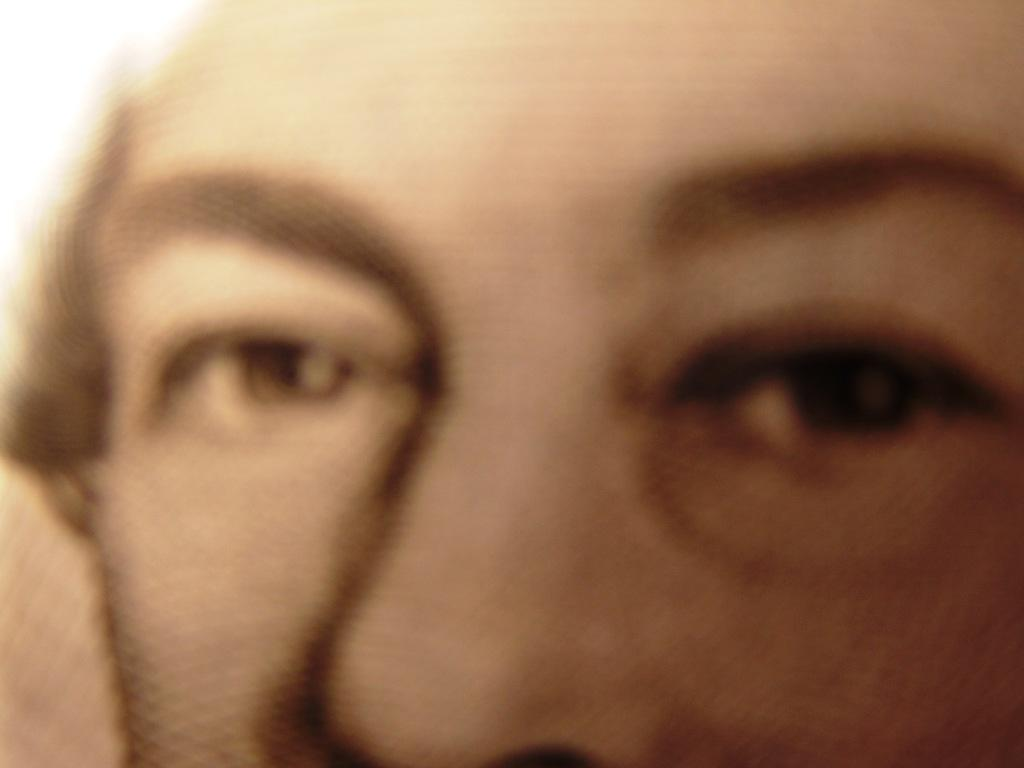What body parts are the focus of the image? The image contains a close-up view of a person's eyes and nose. Can you describe the details of the person's eyes in the image? Unfortunately, the provided facts do not include any details about the person's eyes. Can you describe the details of the person's nose in the image? Unfortunately, the provided facts do not include any details about the person's nose. What type of rifle can be seen in the image? There is no rifle present in the image; it contains a close-up view of a person's eyes and nose. What type of farm animals can be seen in the image? There are no farm animals present in the image; it contains a close-up view of a person's eyes and nose. 